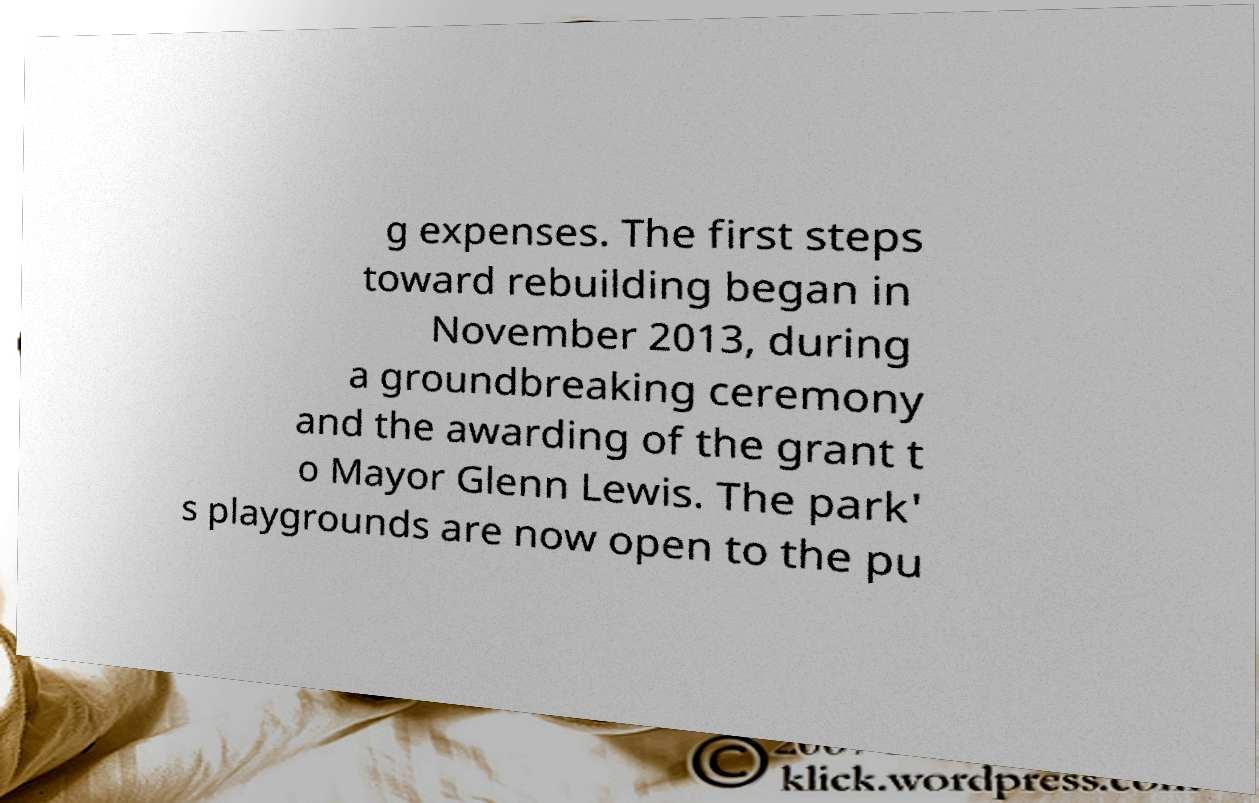Could you extract and type out the text from this image? g expenses. The first steps toward rebuilding began in November 2013, during a groundbreaking ceremony and the awarding of the grant t o Mayor Glenn Lewis. The park' s playgrounds are now open to the pu 